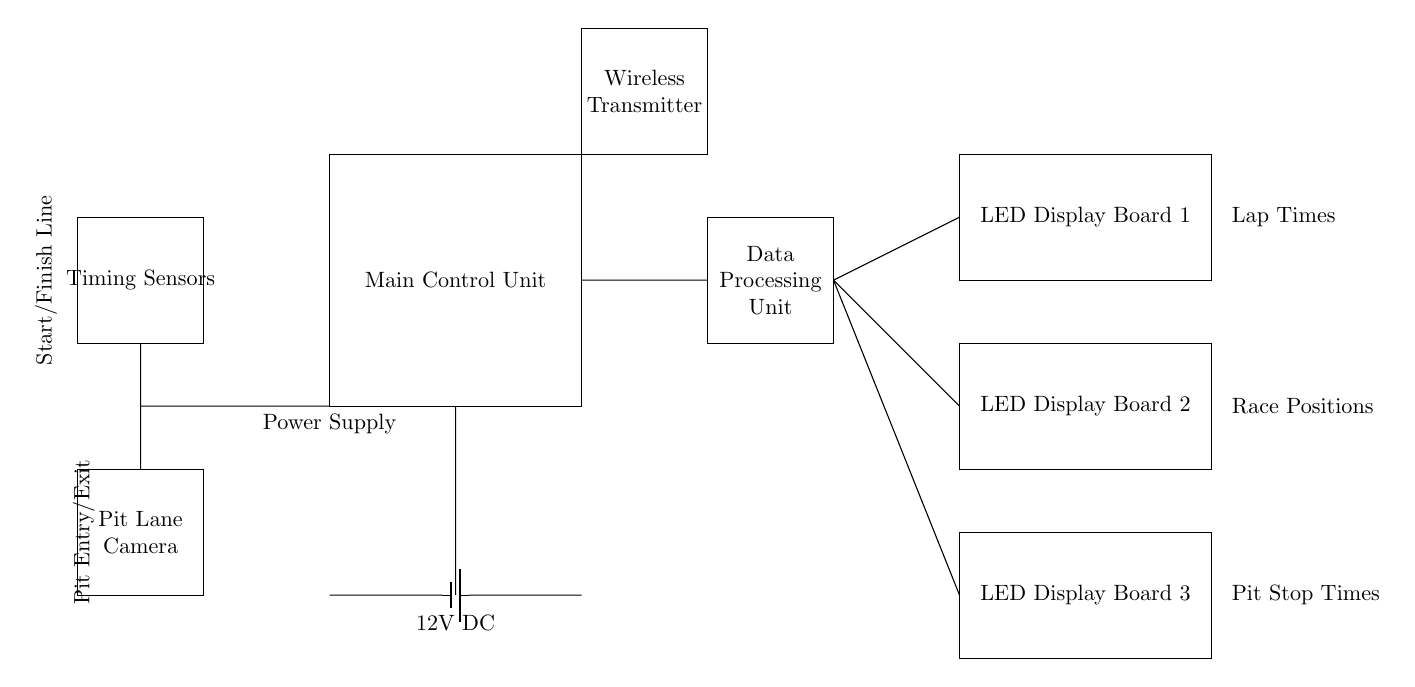What is the function of the main control unit? The main control unit is responsible for managing the overall operation of the timing and scoring system, acting as the central hub for data processing and communication.
Answer: Managing operation What connects the timing sensors to the data processing unit? There is a short connection between the timing sensors and the data processing unit, indicating that data from the timing sensors is directly sent to the unit for processing.
Answer: Short connection How many LED display boards are present in the circuit? The circuit diagram indicates there are three LED display boards, each representing different types of information.
Answer: Three What type of power supply is used? The circuit diagram shows a 12V DC battery as the power supply to power the entire system.
Answer: 12V DC What type of information is displayed on the LED display boards? The LED display boards show lap times, race positions, and pit stop times, which are critical data for monitoring race performance.
Answer: Lap times, race positions, pit stop times Where does the pit lane camera connect in the circuit? The pit lane camera connects to the main control unit through a short connection, allowing it to send video data for analysis.
Answer: Short connection What is the purpose of the wireless transmitter in the circuit? The wireless transmitter is used to communicate data wirelessly, likely transmitting results and statuses to external devices or systems.
Answer: Communicate data wirelessly 